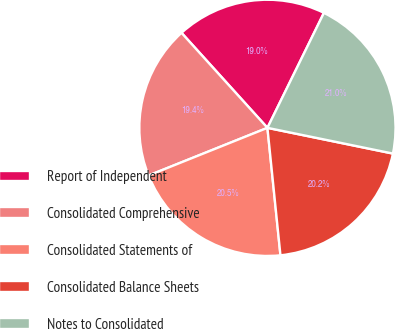Convert chart. <chart><loc_0><loc_0><loc_500><loc_500><pie_chart><fcel>Report of Independent<fcel>Consolidated Comprehensive<fcel>Consolidated Statements of<fcel>Consolidated Balance Sheets<fcel>Notes to Consolidated<nl><fcel>18.97%<fcel>19.37%<fcel>20.55%<fcel>20.16%<fcel>20.95%<nl></chart> 